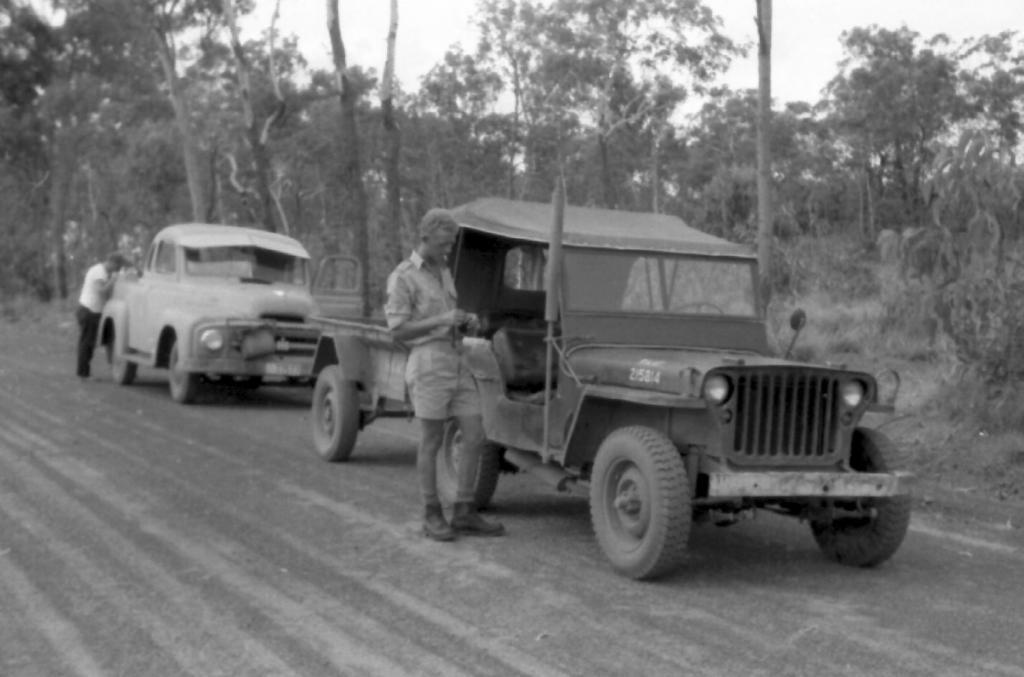Can you describe this image briefly? This is a black and white image. In this image, in the middle, we can see a man standing beside the vehicle. In the middle, we can also see another person standing in front of the car. In the background, we can see some trees and cars. At the top, we can see a sky, at the bottom, we can see land with some stones. 